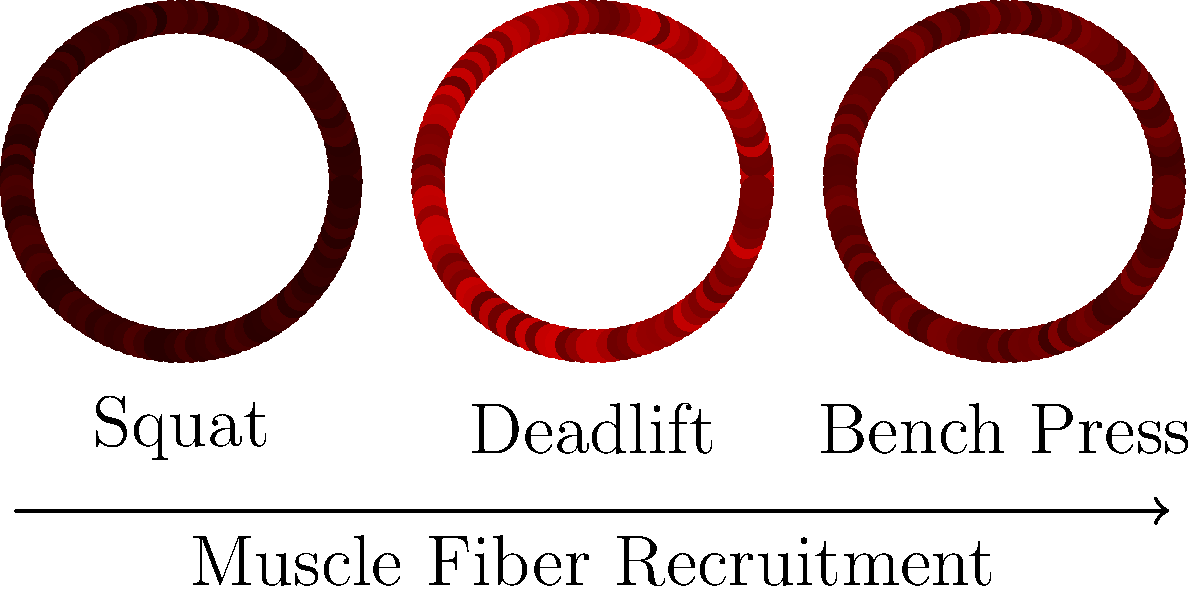Based on the muscle cross-section diagrams representing fiber recruitment patterns during different weightlifting exercises, which exercise demonstrates the highest overall muscle fiber activation? Explain how this relates to the principle of progressive overload in strength training and its potential application in enhancing a martial artist's power output. To answer this question, we need to analyze the muscle fiber recruitment patterns shown in the diagram and understand their implications for strength training and martial arts performance:

1. Analyze the diagram:
   - Squat: Shows relatively low muscle fiber activation (light red)
   - Deadlift: Exhibits the highest muscle fiber activation (dark red)
   - Bench Press: Displays moderate muscle fiber activation (medium red)

2. Identify the exercise with highest activation:
   The deadlift demonstrates the highest overall muscle fiber activation.

3. Understand muscle fiber recruitment:
   - More activated fibers (darker red) indicate greater neural drive and force production
   - Higher activation typically correlates with greater potential for strength gains

4. Relate to progressive overload:
   - Progressive overload involves gradually increasing the stress placed on the body during exercise
   - Exercises with higher muscle fiber recruitment allow for greater potential in applying progressive overload

5. Application to martial arts power output:
   - Martial arts require explosive power and full-body strength
   - Incorporating exercises with high muscle fiber recruitment, like deadlifts, can help develop overall strength and power
   - The ability to recruit more muscle fibers can translate to more forceful strikes and improved performance in martial arts techniques

6. Training implications:
   - Prioritize compound exercises that recruit more muscle fibers
   - Gradually increase weight, volume, or intensity to apply progressive overload
   - Integrate strength training principles into martial arts conditioning for enhanced power development

By understanding and applying these concepts, a weightlifter can effectively help their martial artist sibling improve physical power through targeted strength training exercises that maximize muscle fiber recruitment.
Answer: Deadlift; highest muscle fiber recruitment allows for greater progressive overload potential, leading to increased strength and power development applicable to martial arts performance. 